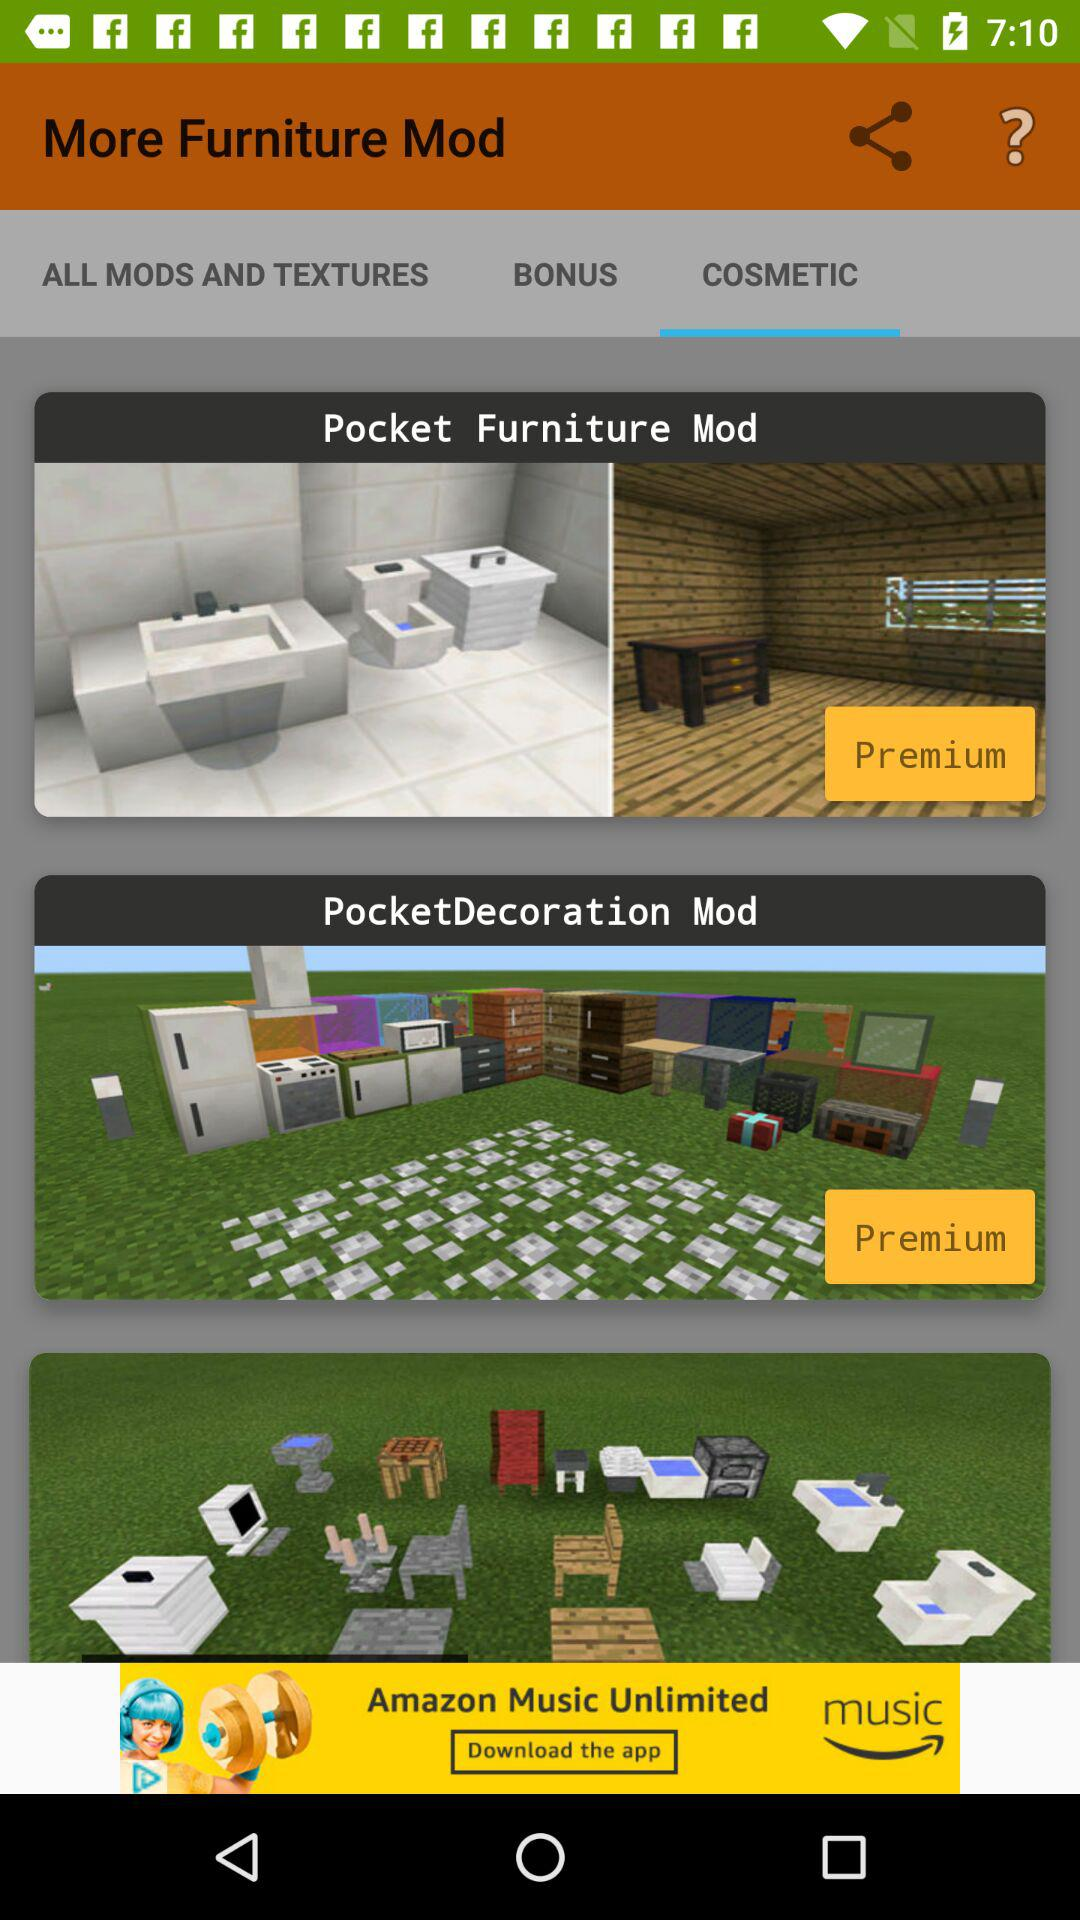Which tab is open? The tab "COSMETIC" is open. 